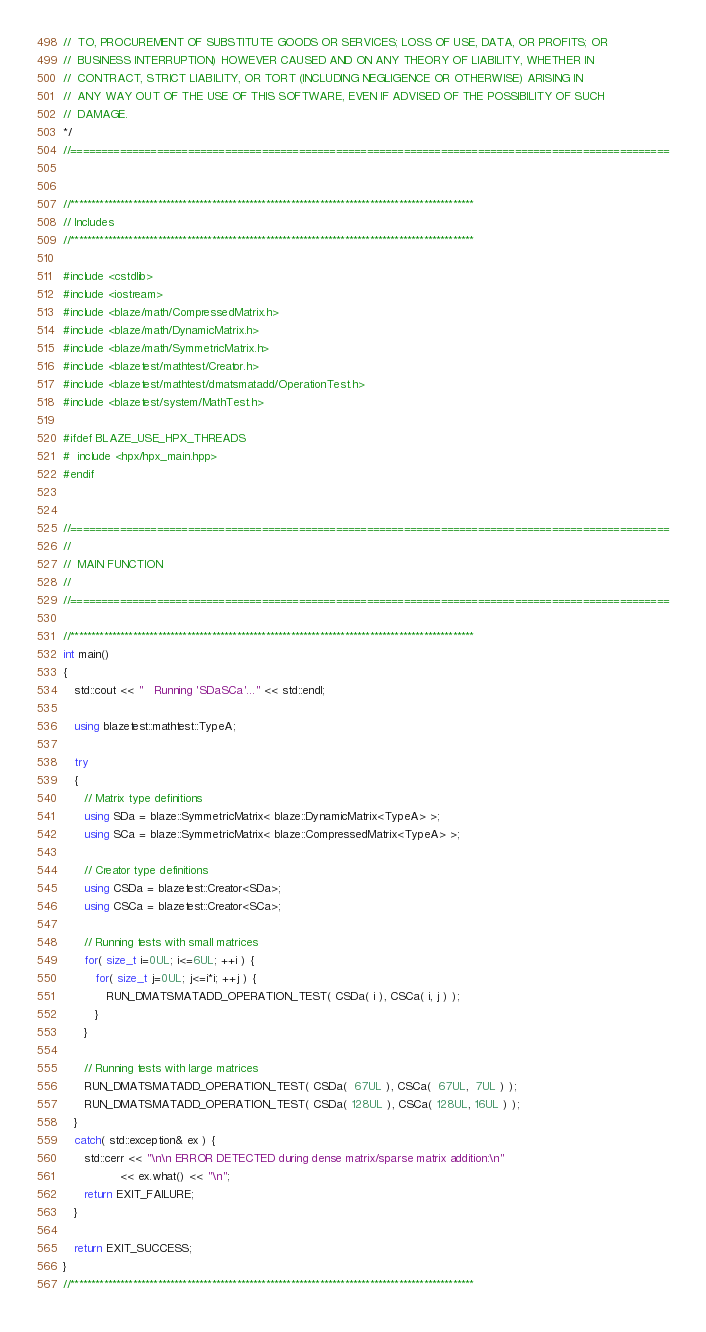<code> <loc_0><loc_0><loc_500><loc_500><_C++_>//  TO, PROCUREMENT OF SUBSTITUTE GOODS OR SERVICES; LOSS OF USE, DATA, OR PROFITS; OR
//  BUSINESS INTERRUPTION) HOWEVER CAUSED AND ON ANY THEORY OF LIABILITY, WHETHER IN
//  CONTRACT, STRICT LIABILITY, OR TORT (INCLUDING NEGLIGENCE OR OTHERWISE) ARISING IN
//  ANY WAY OUT OF THE USE OF THIS SOFTWARE, EVEN IF ADVISED OF THE POSSIBILITY OF SUCH
//  DAMAGE.
*/
//=================================================================================================


//*************************************************************************************************
// Includes
//*************************************************************************************************

#include <cstdlib>
#include <iostream>
#include <blaze/math/CompressedMatrix.h>
#include <blaze/math/DynamicMatrix.h>
#include <blaze/math/SymmetricMatrix.h>
#include <blazetest/mathtest/Creator.h>
#include <blazetest/mathtest/dmatsmatadd/OperationTest.h>
#include <blazetest/system/MathTest.h>

#ifdef BLAZE_USE_HPX_THREADS
#  include <hpx/hpx_main.hpp>
#endif


//=================================================================================================
//
//  MAIN FUNCTION
//
//=================================================================================================

//*************************************************************************************************
int main()
{
   std::cout << "   Running 'SDaSCa'..." << std::endl;

   using blazetest::mathtest::TypeA;

   try
   {
      // Matrix type definitions
      using SDa = blaze::SymmetricMatrix< blaze::DynamicMatrix<TypeA> >;
      using SCa = blaze::SymmetricMatrix< blaze::CompressedMatrix<TypeA> >;

      // Creator type definitions
      using CSDa = blazetest::Creator<SDa>;
      using CSCa = blazetest::Creator<SCa>;

      // Running tests with small matrices
      for( size_t i=0UL; i<=6UL; ++i ) {
         for( size_t j=0UL; j<=i*i; ++j ) {
            RUN_DMATSMATADD_OPERATION_TEST( CSDa( i ), CSCa( i, j ) );
         }
      }

      // Running tests with large matrices
      RUN_DMATSMATADD_OPERATION_TEST( CSDa(  67UL ), CSCa(  67UL,  7UL ) );
      RUN_DMATSMATADD_OPERATION_TEST( CSDa( 128UL ), CSCa( 128UL, 16UL ) );
   }
   catch( std::exception& ex ) {
      std::cerr << "\n\n ERROR DETECTED during dense matrix/sparse matrix addition:\n"
                << ex.what() << "\n";
      return EXIT_FAILURE;
   }

   return EXIT_SUCCESS;
}
//*************************************************************************************************
</code> 